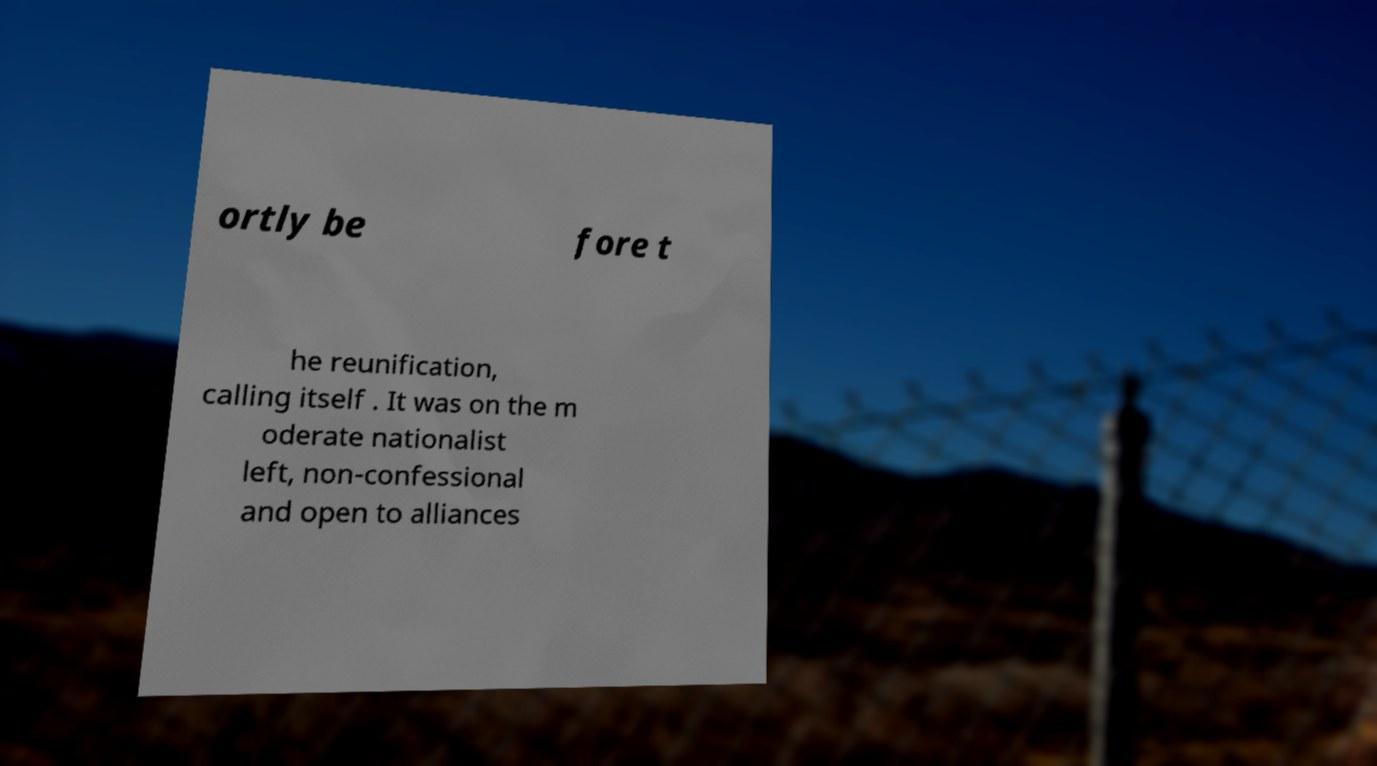Could you extract and type out the text from this image? ortly be fore t he reunification, calling itself . It was on the m oderate nationalist left, non-confessional and open to alliances 